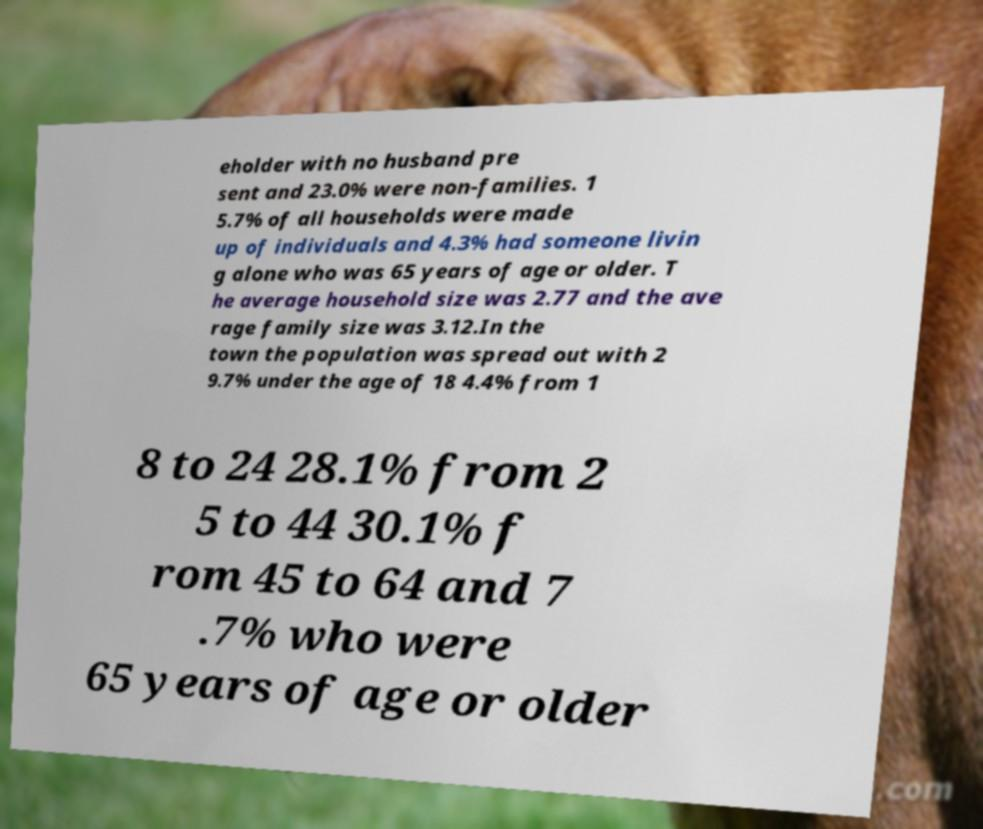Could you assist in decoding the text presented in this image and type it out clearly? eholder with no husband pre sent and 23.0% were non-families. 1 5.7% of all households were made up of individuals and 4.3% had someone livin g alone who was 65 years of age or older. T he average household size was 2.77 and the ave rage family size was 3.12.In the town the population was spread out with 2 9.7% under the age of 18 4.4% from 1 8 to 24 28.1% from 2 5 to 44 30.1% f rom 45 to 64 and 7 .7% who were 65 years of age or older 